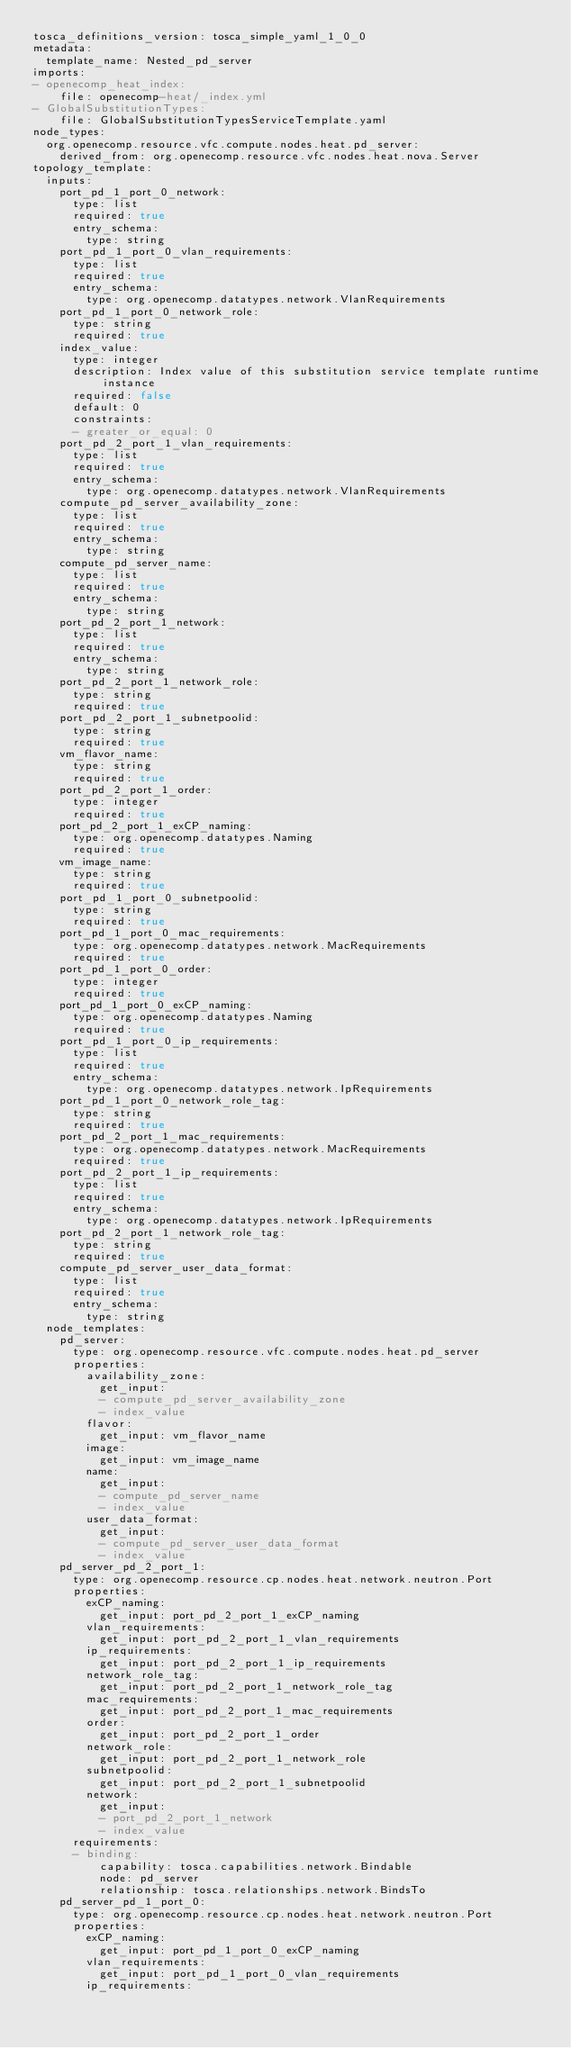Convert code to text. <code><loc_0><loc_0><loc_500><loc_500><_YAML_>tosca_definitions_version: tosca_simple_yaml_1_0_0
metadata:
  template_name: Nested_pd_server
imports:
- openecomp_heat_index:
    file: openecomp-heat/_index.yml
- GlobalSubstitutionTypes:
    file: GlobalSubstitutionTypesServiceTemplate.yaml
node_types:
  org.openecomp.resource.vfc.compute.nodes.heat.pd_server:
    derived_from: org.openecomp.resource.vfc.nodes.heat.nova.Server
topology_template:
  inputs:
    port_pd_1_port_0_network:
      type: list
      required: true
      entry_schema:
        type: string
    port_pd_1_port_0_vlan_requirements:
      type: list
      required: true
      entry_schema:
        type: org.openecomp.datatypes.network.VlanRequirements
    port_pd_1_port_0_network_role:
      type: string
      required: true
    index_value:
      type: integer
      description: Index value of this substitution service template runtime instance
      required: false
      default: 0
      constraints:
      - greater_or_equal: 0
    port_pd_2_port_1_vlan_requirements:
      type: list
      required: true
      entry_schema:
        type: org.openecomp.datatypes.network.VlanRequirements
    compute_pd_server_availability_zone:
      type: list
      required: true
      entry_schema:
        type: string
    compute_pd_server_name:
      type: list
      required: true
      entry_schema:
        type: string
    port_pd_2_port_1_network:
      type: list
      required: true
      entry_schema:
        type: string
    port_pd_2_port_1_network_role:
      type: string
      required: true
    port_pd_2_port_1_subnetpoolid:
      type: string
      required: true
    vm_flavor_name:
      type: string
      required: true
    port_pd_2_port_1_order:
      type: integer
      required: true
    port_pd_2_port_1_exCP_naming:
      type: org.openecomp.datatypes.Naming
      required: true
    vm_image_name:
      type: string
      required: true
    port_pd_1_port_0_subnetpoolid:
      type: string
      required: true
    port_pd_1_port_0_mac_requirements:
      type: org.openecomp.datatypes.network.MacRequirements
      required: true
    port_pd_1_port_0_order:
      type: integer
      required: true
    port_pd_1_port_0_exCP_naming:
      type: org.openecomp.datatypes.Naming
      required: true
    port_pd_1_port_0_ip_requirements:
      type: list
      required: true
      entry_schema:
        type: org.openecomp.datatypes.network.IpRequirements
    port_pd_1_port_0_network_role_tag:
      type: string
      required: true
    port_pd_2_port_1_mac_requirements:
      type: org.openecomp.datatypes.network.MacRequirements
      required: true
    port_pd_2_port_1_ip_requirements:
      type: list
      required: true
      entry_schema:
        type: org.openecomp.datatypes.network.IpRequirements
    port_pd_2_port_1_network_role_tag:
      type: string
      required: true
    compute_pd_server_user_data_format:
      type: list
      required: true
      entry_schema:
        type: string
  node_templates:
    pd_server:
      type: org.openecomp.resource.vfc.compute.nodes.heat.pd_server
      properties:
        availability_zone:
          get_input:
          - compute_pd_server_availability_zone
          - index_value
        flavor:
          get_input: vm_flavor_name
        image:
          get_input: vm_image_name
        name:
          get_input:
          - compute_pd_server_name
          - index_value
        user_data_format:
          get_input:
          - compute_pd_server_user_data_format
          - index_value
    pd_server_pd_2_port_1:
      type: org.openecomp.resource.cp.nodes.heat.network.neutron.Port
      properties:
        exCP_naming:
          get_input: port_pd_2_port_1_exCP_naming
        vlan_requirements:
          get_input: port_pd_2_port_1_vlan_requirements
        ip_requirements:
          get_input: port_pd_2_port_1_ip_requirements
        network_role_tag:
          get_input: port_pd_2_port_1_network_role_tag
        mac_requirements:
          get_input: port_pd_2_port_1_mac_requirements
        order:
          get_input: port_pd_2_port_1_order
        network_role:
          get_input: port_pd_2_port_1_network_role
        subnetpoolid:
          get_input: port_pd_2_port_1_subnetpoolid
        network:
          get_input:
          - port_pd_2_port_1_network
          - index_value
      requirements:
      - binding:
          capability: tosca.capabilities.network.Bindable
          node: pd_server
          relationship: tosca.relationships.network.BindsTo
    pd_server_pd_1_port_0:
      type: org.openecomp.resource.cp.nodes.heat.network.neutron.Port
      properties:
        exCP_naming:
          get_input: port_pd_1_port_0_exCP_naming
        vlan_requirements:
          get_input: port_pd_1_port_0_vlan_requirements
        ip_requirements:</code> 